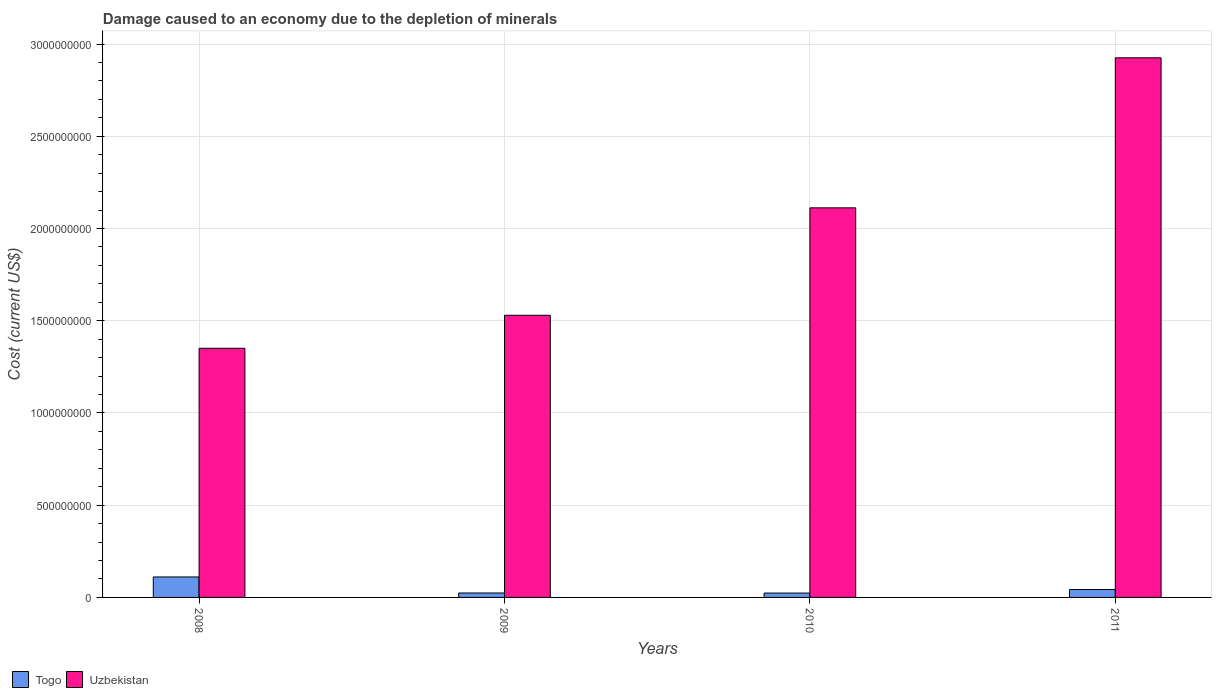How many different coloured bars are there?
Provide a short and direct response. 2. Are the number of bars per tick equal to the number of legend labels?
Offer a very short reply. Yes. Are the number of bars on each tick of the X-axis equal?
Offer a very short reply. Yes. How many bars are there on the 1st tick from the left?
Ensure brevity in your answer.  2. How many bars are there on the 4th tick from the right?
Provide a succinct answer. 2. What is the label of the 2nd group of bars from the left?
Your answer should be compact. 2009. What is the cost of damage caused due to the depletion of minerals in Uzbekistan in 2008?
Ensure brevity in your answer.  1.35e+09. Across all years, what is the maximum cost of damage caused due to the depletion of minerals in Uzbekistan?
Your response must be concise. 2.93e+09. Across all years, what is the minimum cost of damage caused due to the depletion of minerals in Uzbekistan?
Keep it short and to the point. 1.35e+09. In which year was the cost of damage caused due to the depletion of minerals in Togo minimum?
Your answer should be very brief. 2010. What is the total cost of damage caused due to the depletion of minerals in Uzbekistan in the graph?
Provide a short and direct response. 7.92e+09. What is the difference between the cost of damage caused due to the depletion of minerals in Uzbekistan in 2009 and that in 2010?
Keep it short and to the point. -5.83e+08. What is the difference between the cost of damage caused due to the depletion of minerals in Togo in 2010 and the cost of damage caused due to the depletion of minerals in Uzbekistan in 2009?
Ensure brevity in your answer.  -1.51e+09. What is the average cost of damage caused due to the depletion of minerals in Togo per year?
Your answer should be compact. 5.04e+07. In the year 2010, what is the difference between the cost of damage caused due to the depletion of minerals in Uzbekistan and cost of damage caused due to the depletion of minerals in Togo?
Make the answer very short. 2.09e+09. In how many years, is the cost of damage caused due to the depletion of minerals in Togo greater than 2900000000 US$?
Offer a terse response. 0. What is the ratio of the cost of damage caused due to the depletion of minerals in Togo in 2008 to that in 2009?
Make the answer very short. 4.61. What is the difference between the highest and the second highest cost of damage caused due to the depletion of minerals in Togo?
Give a very brief answer. 6.82e+07. What is the difference between the highest and the lowest cost of damage caused due to the depletion of minerals in Togo?
Provide a short and direct response. 8.72e+07. Is the sum of the cost of damage caused due to the depletion of minerals in Uzbekistan in 2009 and 2010 greater than the maximum cost of damage caused due to the depletion of minerals in Togo across all years?
Keep it short and to the point. Yes. What does the 1st bar from the left in 2011 represents?
Provide a succinct answer. Togo. What does the 2nd bar from the right in 2008 represents?
Offer a very short reply. Togo. Are all the bars in the graph horizontal?
Give a very brief answer. No. How many years are there in the graph?
Your answer should be very brief. 4. What is the difference between two consecutive major ticks on the Y-axis?
Provide a succinct answer. 5.00e+08. Does the graph contain any zero values?
Offer a terse response. No. Does the graph contain grids?
Offer a very short reply. Yes. Where does the legend appear in the graph?
Provide a short and direct response. Bottom left. How many legend labels are there?
Your answer should be compact. 2. What is the title of the graph?
Offer a terse response. Damage caused to an economy due to the depletion of minerals. What is the label or title of the Y-axis?
Your response must be concise. Cost (current US$). What is the Cost (current US$) in Togo in 2008?
Make the answer very short. 1.11e+08. What is the Cost (current US$) of Uzbekistan in 2008?
Offer a very short reply. 1.35e+09. What is the Cost (current US$) in Togo in 2009?
Keep it short and to the point. 2.41e+07. What is the Cost (current US$) in Uzbekistan in 2009?
Ensure brevity in your answer.  1.53e+09. What is the Cost (current US$) of Togo in 2010?
Give a very brief answer. 2.37e+07. What is the Cost (current US$) of Uzbekistan in 2010?
Make the answer very short. 2.11e+09. What is the Cost (current US$) of Togo in 2011?
Your answer should be very brief. 4.28e+07. What is the Cost (current US$) of Uzbekistan in 2011?
Provide a short and direct response. 2.93e+09. Across all years, what is the maximum Cost (current US$) in Togo?
Ensure brevity in your answer.  1.11e+08. Across all years, what is the maximum Cost (current US$) in Uzbekistan?
Give a very brief answer. 2.93e+09. Across all years, what is the minimum Cost (current US$) of Togo?
Keep it short and to the point. 2.37e+07. Across all years, what is the minimum Cost (current US$) of Uzbekistan?
Your answer should be compact. 1.35e+09. What is the total Cost (current US$) of Togo in the graph?
Make the answer very short. 2.02e+08. What is the total Cost (current US$) of Uzbekistan in the graph?
Your response must be concise. 7.92e+09. What is the difference between the Cost (current US$) in Togo in 2008 and that in 2009?
Provide a succinct answer. 8.69e+07. What is the difference between the Cost (current US$) of Uzbekistan in 2008 and that in 2009?
Offer a terse response. -1.79e+08. What is the difference between the Cost (current US$) in Togo in 2008 and that in 2010?
Your answer should be very brief. 8.72e+07. What is the difference between the Cost (current US$) of Uzbekistan in 2008 and that in 2010?
Your response must be concise. -7.62e+08. What is the difference between the Cost (current US$) in Togo in 2008 and that in 2011?
Give a very brief answer. 6.82e+07. What is the difference between the Cost (current US$) in Uzbekistan in 2008 and that in 2011?
Give a very brief answer. -1.57e+09. What is the difference between the Cost (current US$) in Togo in 2009 and that in 2010?
Your answer should be compact. 3.20e+05. What is the difference between the Cost (current US$) of Uzbekistan in 2009 and that in 2010?
Provide a succinct answer. -5.83e+08. What is the difference between the Cost (current US$) of Togo in 2009 and that in 2011?
Ensure brevity in your answer.  -1.88e+07. What is the difference between the Cost (current US$) in Uzbekistan in 2009 and that in 2011?
Provide a short and direct response. -1.40e+09. What is the difference between the Cost (current US$) in Togo in 2010 and that in 2011?
Offer a very short reply. -1.91e+07. What is the difference between the Cost (current US$) in Uzbekistan in 2010 and that in 2011?
Provide a succinct answer. -8.13e+08. What is the difference between the Cost (current US$) in Togo in 2008 and the Cost (current US$) in Uzbekistan in 2009?
Your response must be concise. -1.42e+09. What is the difference between the Cost (current US$) in Togo in 2008 and the Cost (current US$) in Uzbekistan in 2010?
Make the answer very short. -2.00e+09. What is the difference between the Cost (current US$) in Togo in 2008 and the Cost (current US$) in Uzbekistan in 2011?
Make the answer very short. -2.81e+09. What is the difference between the Cost (current US$) of Togo in 2009 and the Cost (current US$) of Uzbekistan in 2010?
Keep it short and to the point. -2.09e+09. What is the difference between the Cost (current US$) in Togo in 2009 and the Cost (current US$) in Uzbekistan in 2011?
Offer a very short reply. -2.90e+09. What is the difference between the Cost (current US$) in Togo in 2010 and the Cost (current US$) in Uzbekistan in 2011?
Keep it short and to the point. -2.90e+09. What is the average Cost (current US$) of Togo per year?
Give a very brief answer. 5.04e+07. What is the average Cost (current US$) in Uzbekistan per year?
Offer a very short reply. 1.98e+09. In the year 2008, what is the difference between the Cost (current US$) in Togo and Cost (current US$) in Uzbekistan?
Provide a succinct answer. -1.24e+09. In the year 2009, what is the difference between the Cost (current US$) in Togo and Cost (current US$) in Uzbekistan?
Provide a short and direct response. -1.51e+09. In the year 2010, what is the difference between the Cost (current US$) in Togo and Cost (current US$) in Uzbekistan?
Your answer should be very brief. -2.09e+09. In the year 2011, what is the difference between the Cost (current US$) in Togo and Cost (current US$) in Uzbekistan?
Provide a short and direct response. -2.88e+09. What is the ratio of the Cost (current US$) in Togo in 2008 to that in 2009?
Provide a succinct answer. 4.61. What is the ratio of the Cost (current US$) of Uzbekistan in 2008 to that in 2009?
Your response must be concise. 0.88. What is the ratio of the Cost (current US$) of Togo in 2008 to that in 2010?
Ensure brevity in your answer.  4.68. What is the ratio of the Cost (current US$) of Uzbekistan in 2008 to that in 2010?
Give a very brief answer. 0.64. What is the ratio of the Cost (current US$) of Togo in 2008 to that in 2011?
Your answer should be compact. 2.59. What is the ratio of the Cost (current US$) of Uzbekistan in 2008 to that in 2011?
Offer a very short reply. 0.46. What is the ratio of the Cost (current US$) in Togo in 2009 to that in 2010?
Your answer should be very brief. 1.01. What is the ratio of the Cost (current US$) in Uzbekistan in 2009 to that in 2010?
Your response must be concise. 0.72. What is the ratio of the Cost (current US$) in Togo in 2009 to that in 2011?
Give a very brief answer. 0.56. What is the ratio of the Cost (current US$) of Uzbekistan in 2009 to that in 2011?
Make the answer very short. 0.52. What is the ratio of the Cost (current US$) in Togo in 2010 to that in 2011?
Keep it short and to the point. 0.55. What is the ratio of the Cost (current US$) in Uzbekistan in 2010 to that in 2011?
Make the answer very short. 0.72. What is the difference between the highest and the second highest Cost (current US$) of Togo?
Your response must be concise. 6.82e+07. What is the difference between the highest and the second highest Cost (current US$) in Uzbekistan?
Provide a succinct answer. 8.13e+08. What is the difference between the highest and the lowest Cost (current US$) of Togo?
Offer a terse response. 8.72e+07. What is the difference between the highest and the lowest Cost (current US$) in Uzbekistan?
Offer a terse response. 1.57e+09. 